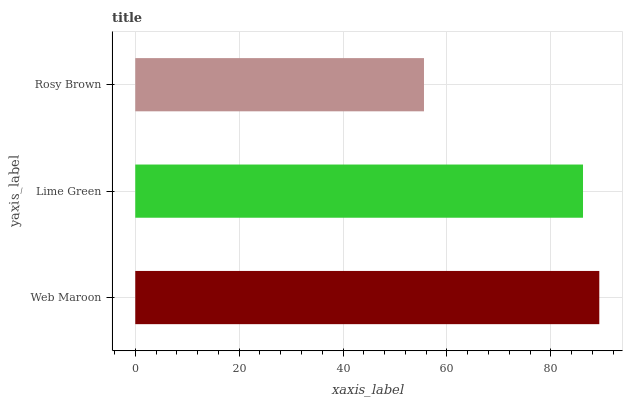Is Rosy Brown the minimum?
Answer yes or no. Yes. Is Web Maroon the maximum?
Answer yes or no. Yes. Is Lime Green the minimum?
Answer yes or no. No. Is Lime Green the maximum?
Answer yes or no. No. Is Web Maroon greater than Lime Green?
Answer yes or no. Yes. Is Lime Green less than Web Maroon?
Answer yes or no. Yes. Is Lime Green greater than Web Maroon?
Answer yes or no. No. Is Web Maroon less than Lime Green?
Answer yes or no. No. Is Lime Green the high median?
Answer yes or no. Yes. Is Lime Green the low median?
Answer yes or no. Yes. Is Rosy Brown the high median?
Answer yes or no. No. Is Rosy Brown the low median?
Answer yes or no. No. 